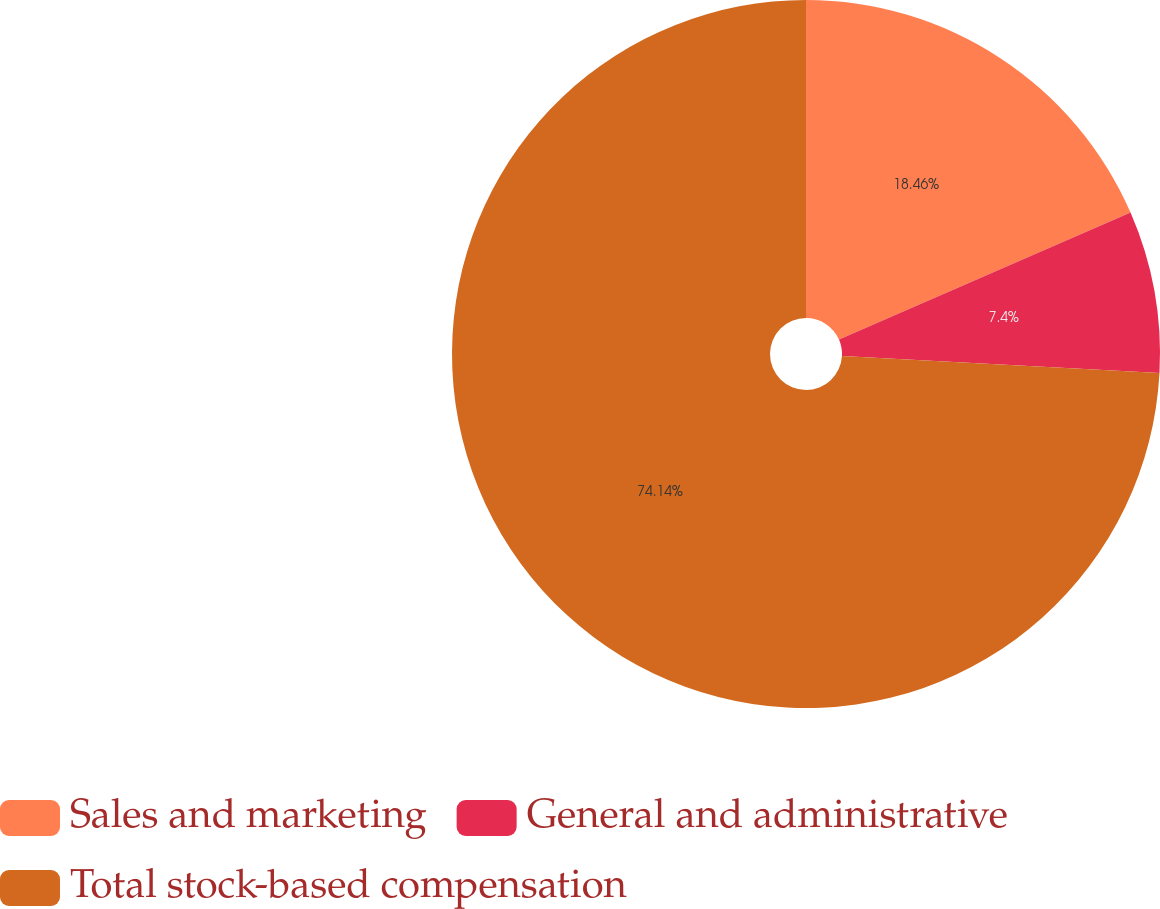<chart> <loc_0><loc_0><loc_500><loc_500><pie_chart><fcel>Sales and marketing<fcel>General and administrative<fcel>Total stock-based compensation<nl><fcel>18.46%<fcel>7.4%<fcel>74.14%<nl></chart> 